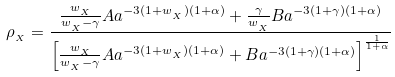Convert formula to latex. <formula><loc_0><loc_0><loc_500><loc_500>\rho _ { _ { X } } = \frac { \frac { w _ { _ { X } } } { w _ { _ { X } } - \gamma } A a ^ { - 3 ( 1 + w _ { _ { X } } ) ( 1 + \alpha ) } + \frac { \gamma } { w _ { _ { X } } } B a ^ { - 3 ( 1 + \gamma ) ( 1 + \alpha ) } } { \left [ \frac { w _ { _ { X } } } { w _ { _ { X } } - \gamma } A a ^ { - 3 ( 1 + w _ { _ { X } } ) ( 1 + \alpha ) } + B a ^ { - 3 ( 1 + \gamma ) ( 1 + \alpha ) } \right ] ^ { \frac { 1 } { 1 + \alpha } } }</formula> 